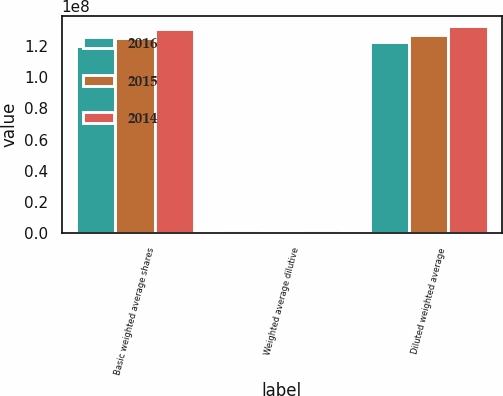Convert chart to OTSL. <chart><loc_0><loc_0><loc_500><loc_500><stacked_bar_chart><ecel><fcel>Basic weighted average shares<fcel>Weighted average dilutive<fcel>Diluted weighted average<nl><fcel>2016<fcel>1.20001e+08<fcel>2.36659e+06<fcel>1.22368e+08<nl><fcel>2015<fcel>1.25095e+08<fcel>1.66261e+06<fcel>1.26757e+08<nl><fcel>2014<fcel>1.30722e+08<fcel>1.91851e+06<fcel>1.3264e+08<nl></chart> 